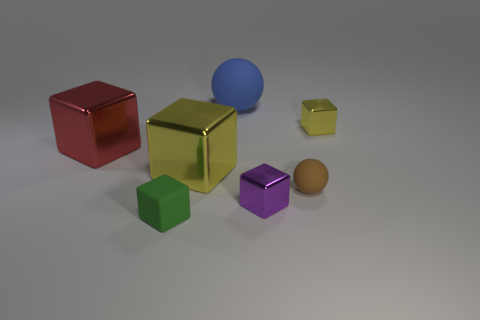What number of brown spheres are to the right of the tiny rubber thing to the right of the blue thing?
Your answer should be compact. 0. What number of things are either rubber things on the left side of the purple cube or small spheres?
Your answer should be compact. 3. How many tiny brown spheres are made of the same material as the green cube?
Your answer should be compact. 1. Are there the same number of purple things that are behind the large blue matte object and small brown things?
Make the answer very short. No. There is a matte cube to the left of the blue rubber ball; what is its size?
Your response must be concise. Small. How many tiny things are either brown matte objects or purple cubes?
Give a very brief answer. 2. There is another large metallic thing that is the same shape as the big red metallic object; what is its color?
Offer a very short reply. Yellow. Do the purple shiny cube and the rubber cube have the same size?
Your answer should be compact. Yes. How many things are blocks or things behind the small brown matte thing?
Your answer should be very brief. 6. The rubber thing to the left of the ball that is to the left of the small brown matte ball is what color?
Make the answer very short. Green. 